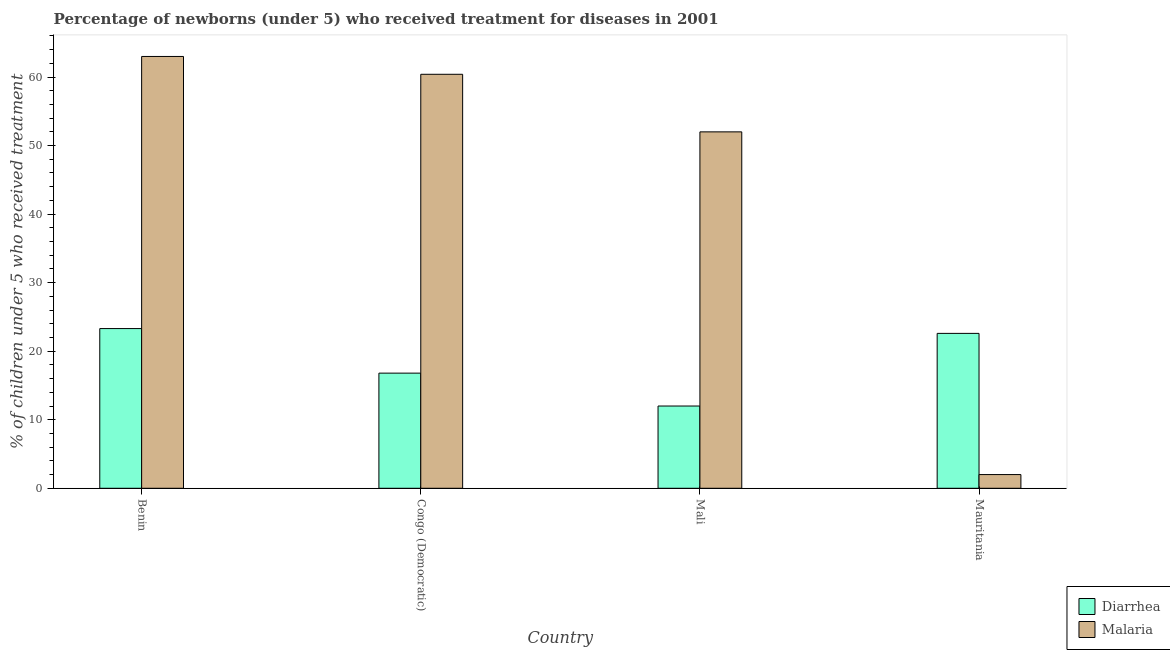How many bars are there on the 2nd tick from the right?
Make the answer very short. 2. What is the label of the 4th group of bars from the left?
Provide a short and direct response. Mauritania. What is the percentage of children who received treatment for malaria in Mauritania?
Keep it short and to the point. 2. Across all countries, what is the maximum percentage of children who received treatment for malaria?
Offer a very short reply. 63. In which country was the percentage of children who received treatment for diarrhoea maximum?
Ensure brevity in your answer.  Benin. In which country was the percentage of children who received treatment for diarrhoea minimum?
Offer a very short reply. Mali. What is the total percentage of children who received treatment for malaria in the graph?
Give a very brief answer. 177.4. What is the difference between the percentage of children who received treatment for malaria in Congo (Democratic) and that in Mauritania?
Make the answer very short. 58.4. What is the difference between the percentage of children who received treatment for malaria in Mauritania and the percentage of children who received treatment for diarrhoea in Benin?
Your response must be concise. -21.3. What is the average percentage of children who received treatment for malaria per country?
Your response must be concise. 44.35. What is the difference between the percentage of children who received treatment for malaria and percentage of children who received treatment for diarrhoea in Benin?
Offer a terse response. 39.7. What is the ratio of the percentage of children who received treatment for diarrhoea in Benin to that in Congo (Democratic)?
Make the answer very short. 1.39. Is the difference between the percentage of children who received treatment for malaria in Congo (Democratic) and Mali greater than the difference between the percentage of children who received treatment for diarrhoea in Congo (Democratic) and Mali?
Your response must be concise. Yes. What is the difference between the highest and the second highest percentage of children who received treatment for malaria?
Provide a succinct answer. 2.6. What is the difference between the highest and the lowest percentage of children who received treatment for diarrhoea?
Provide a short and direct response. 11.3. What does the 1st bar from the left in Mali represents?
Your answer should be compact. Diarrhea. What does the 2nd bar from the right in Mali represents?
Offer a very short reply. Diarrhea. How many countries are there in the graph?
Your response must be concise. 4. Where does the legend appear in the graph?
Your answer should be compact. Bottom right. How many legend labels are there?
Your response must be concise. 2. What is the title of the graph?
Offer a terse response. Percentage of newborns (under 5) who received treatment for diseases in 2001. What is the label or title of the X-axis?
Your response must be concise. Country. What is the label or title of the Y-axis?
Your response must be concise. % of children under 5 who received treatment. What is the % of children under 5 who received treatment in Diarrhea in Benin?
Make the answer very short. 23.3. What is the % of children under 5 who received treatment of Diarrhea in Congo (Democratic)?
Ensure brevity in your answer.  16.8. What is the % of children under 5 who received treatment in Malaria in Congo (Democratic)?
Your answer should be very brief. 60.4. What is the % of children under 5 who received treatment of Diarrhea in Mali?
Offer a very short reply. 12. What is the % of children under 5 who received treatment of Diarrhea in Mauritania?
Provide a short and direct response. 22.6. What is the % of children under 5 who received treatment of Malaria in Mauritania?
Ensure brevity in your answer.  2. Across all countries, what is the maximum % of children under 5 who received treatment of Diarrhea?
Make the answer very short. 23.3. Across all countries, what is the maximum % of children under 5 who received treatment in Malaria?
Offer a very short reply. 63. Across all countries, what is the minimum % of children under 5 who received treatment of Diarrhea?
Offer a very short reply. 12. What is the total % of children under 5 who received treatment of Diarrhea in the graph?
Make the answer very short. 74.7. What is the total % of children under 5 who received treatment in Malaria in the graph?
Your answer should be very brief. 177.4. What is the difference between the % of children under 5 who received treatment in Diarrhea in Benin and that in Mali?
Give a very brief answer. 11.3. What is the difference between the % of children under 5 who received treatment of Malaria in Benin and that in Mali?
Your answer should be compact. 11. What is the difference between the % of children under 5 who received treatment in Diarrhea in Benin and that in Mauritania?
Ensure brevity in your answer.  0.7. What is the difference between the % of children under 5 who received treatment of Diarrhea in Congo (Democratic) and that in Mali?
Your answer should be very brief. 4.8. What is the difference between the % of children under 5 who received treatment in Malaria in Congo (Democratic) and that in Mali?
Ensure brevity in your answer.  8.4. What is the difference between the % of children under 5 who received treatment in Diarrhea in Congo (Democratic) and that in Mauritania?
Give a very brief answer. -5.8. What is the difference between the % of children under 5 who received treatment of Malaria in Congo (Democratic) and that in Mauritania?
Offer a terse response. 58.4. What is the difference between the % of children under 5 who received treatment of Malaria in Mali and that in Mauritania?
Offer a very short reply. 50. What is the difference between the % of children under 5 who received treatment of Diarrhea in Benin and the % of children under 5 who received treatment of Malaria in Congo (Democratic)?
Offer a terse response. -37.1. What is the difference between the % of children under 5 who received treatment in Diarrhea in Benin and the % of children under 5 who received treatment in Malaria in Mali?
Make the answer very short. -28.7. What is the difference between the % of children under 5 who received treatment of Diarrhea in Benin and the % of children under 5 who received treatment of Malaria in Mauritania?
Offer a terse response. 21.3. What is the difference between the % of children under 5 who received treatment in Diarrhea in Congo (Democratic) and the % of children under 5 who received treatment in Malaria in Mali?
Give a very brief answer. -35.2. What is the average % of children under 5 who received treatment of Diarrhea per country?
Provide a short and direct response. 18.68. What is the average % of children under 5 who received treatment in Malaria per country?
Ensure brevity in your answer.  44.35. What is the difference between the % of children under 5 who received treatment of Diarrhea and % of children under 5 who received treatment of Malaria in Benin?
Your response must be concise. -39.7. What is the difference between the % of children under 5 who received treatment in Diarrhea and % of children under 5 who received treatment in Malaria in Congo (Democratic)?
Provide a succinct answer. -43.6. What is the difference between the % of children under 5 who received treatment of Diarrhea and % of children under 5 who received treatment of Malaria in Mauritania?
Provide a short and direct response. 20.6. What is the ratio of the % of children under 5 who received treatment of Diarrhea in Benin to that in Congo (Democratic)?
Offer a very short reply. 1.39. What is the ratio of the % of children under 5 who received treatment of Malaria in Benin to that in Congo (Democratic)?
Ensure brevity in your answer.  1.04. What is the ratio of the % of children under 5 who received treatment of Diarrhea in Benin to that in Mali?
Your answer should be very brief. 1.94. What is the ratio of the % of children under 5 who received treatment in Malaria in Benin to that in Mali?
Your response must be concise. 1.21. What is the ratio of the % of children under 5 who received treatment of Diarrhea in Benin to that in Mauritania?
Your response must be concise. 1.03. What is the ratio of the % of children under 5 who received treatment of Malaria in Benin to that in Mauritania?
Your answer should be very brief. 31.5. What is the ratio of the % of children under 5 who received treatment of Diarrhea in Congo (Democratic) to that in Mali?
Give a very brief answer. 1.4. What is the ratio of the % of children under 5 who received treatment of Malaria in Congo (Democratic) to that in Mali?
Ensure brevity in your answer.  1.16. What is the ratio of the % of children under 5 who received treatment in Diarrhea in Congo (Democratic) to that in Mauritania?
Offer a very short reply. 0.74. What is the ratio of the % of children under 5 who received treatment in Malaria in Congo (Democratic) to that in Mauritania?
Keep it short and to the point. 30.2. What is the ratio of the % of children under 5 who received treatment in Diarrhea in Mali to that in Mauritania?
Make the answer very short. 0.53. 